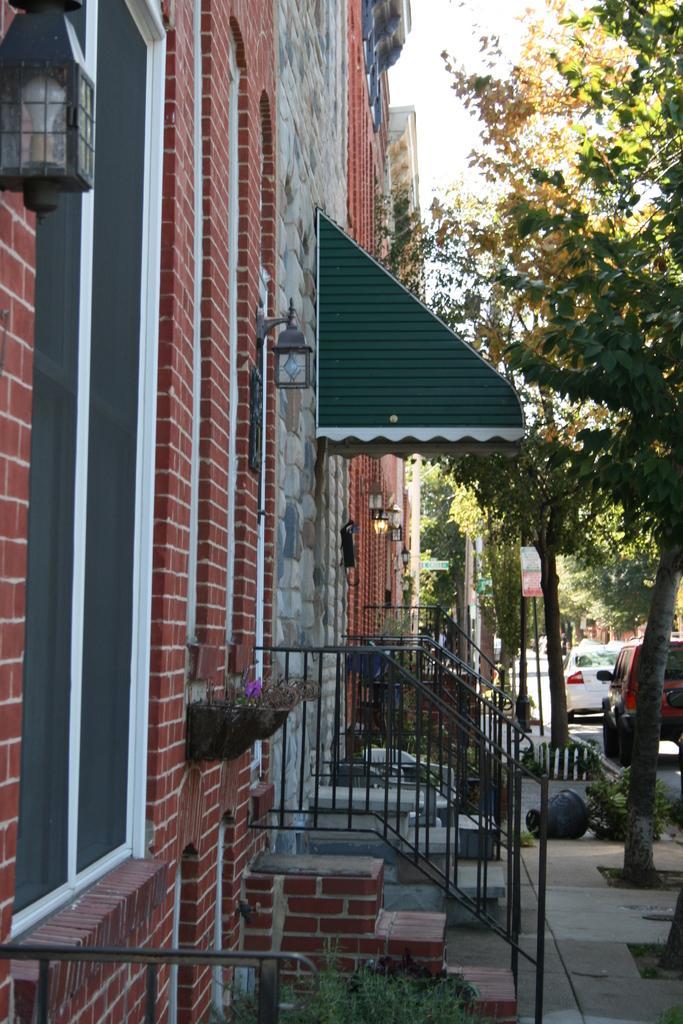Describe this image in one or two sentences. It is a street and in the left side there are many houses and there are steps in front of the houses,beside the steps there are many trees and to the right side of the footpath there are two vehicles parked on the road. 